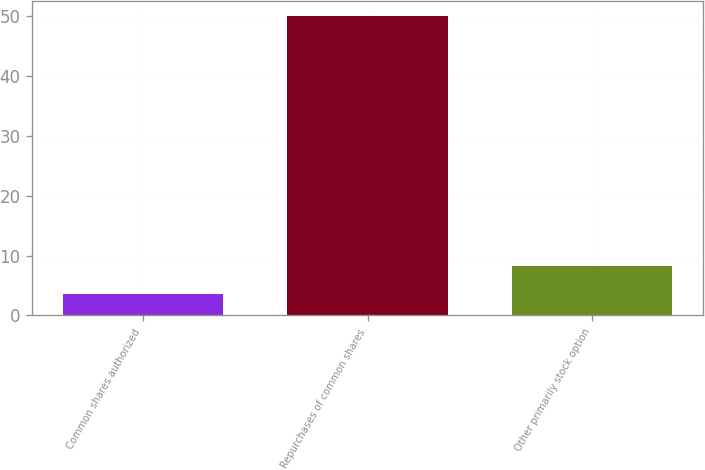Convert chart to OTSL. <chart><loc_0><loc_0><loc_500><loc_500><bar_chart><fcel>Common shares authorized<fcel>Repurchases of common shares<fcel>Other primarily stock option<nl><fcel>3.6<fcel>50<fcel>8.24<nl></chart> 